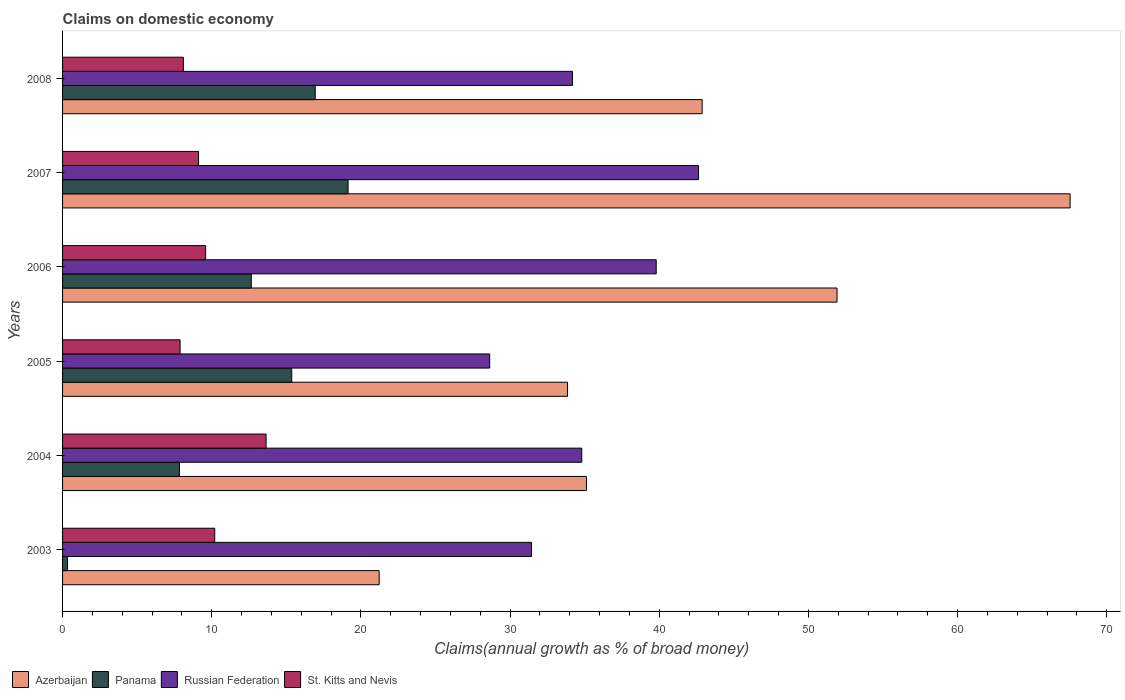How many groups of bars are there?
Your answer should be very brief. 6. Are the number of bars per tick equal to the number of legend labels?
Provide a succinct answer. Yes. How many bars are there on the 1st tick from the top?
Your answer should be compact. 4. How many bars are there on the 3rd tick from the bottom?
Provide a short and direct response. 4. In how many cases, is the number of bars for a given year not equal to the number of legend labels?
Your response must be concise. 0. What is the percentage of broad money claimed on domestic economy in Russian Federation in 2006?
Provide a succinct answer. 39.8. Across all years, what is the maximum percentage of broad money claimed on domestic economy in Azerbaijan?
Ensure brevity in your answer.  67.55. Across all years, what is the minimum percentage of broad money claimed on domestic economy in Azerbaijan?
Give a very brief answer. 21.23. In which year was the percentage of broad money claimed on domestic economy in Azerbaijan maximum?
Offer a very short reply. 2007. What is the total percentage of broad money claimed on domestic economy in Russian Federation in the graph?
Your response must be concise. 211.51. What is the difference between the percentage of broad money claimed on domestic economy in Russian Federation in 2005 and that in 2007?
Offer a terse response. -14. What is the difference between the percentage of broad money claimed on domestic economy in Panama in 2004 and the percentage of broad money claimed on domestic economy in Azerbaijan in 2007?
Provide a succinct answer. -59.71. What is the average percentage of broad money claimed on domestic economy in Azerbaijan per year?
Keep it short and to the point. 42.09. In the year 2004, what is the difference between the percentage of broad money claimed on domestic economy in Panama and percentage of broad money claimed on domestic economy in Azerbaijan?
Your response must be concise. -27.29. In how many years, is the percentage of broad money claimed on domestic economy in Panama greater than 58 %?
Offer a terse response. 0. What is the ratio of the percentage of broad money claimed on domestic economy in Russian Federation in 2003 to that in 2004?
Provide a short and direct response. 0.9. Is the percentage of broad money claimed on domestic economy in Russian Federation in 2006 less than that in 2008?
Provide a short and direct response. No. What is the difference between the highest and the second highest percentage of broad money claimed on domestic economy in Panama?
Keep it short and to the point. 2.2. What is the difference between the highest and the lowest percentage of broad money claimed on domestic economy in Panama?
Give a very brief answer. 18.81. Is the sum of the percentage of broad money claimed on domestic economy in Azerbaijan in 2004 and 2006 greater than the maximum percentage of broad money claimed on domestic economy in St. Kitts and Nevis across all years?
Offer a terse response. Yes. Is it the case that in every year, the sum of the percentage of broad money claimed on domestic economy in Russian Federation and percentage of broad money claimed on domestic economy in Panama is greater than the sum of percentage of broad money claimed on domestic economy in St. Kitts and Nevis and percentage of broad money claimed on domestic economy in Azerbaijan?
Ensure brevity in your answer.  No. What does the 4th bar from the top in 2008 represents?
Your answer should be very brief. Azerbaijan. What does the 2nd bar from the bottom in 2004 represents?
Provide a short and direct response. Panama. How many bars are there?
Provide a succinct answer. 24. Are all the bars in the graph horizontal?
Your answer should be compact. Yes. How many years are there in the graph?
Ensure brevity in your answer.  6. Does the graph contain any zero values?
Offer a very short reply. No. What is the title of the graph?
Your answer should be compact. Claims on domestic economy. What is the label or title of the X-axis?
Offer a terse response. Claims(annual growth as % of broad money). What is the label or title of the Y-axis?
Make the answer very short. Years. What is the Claims(annual growth as % of broad money) of Azerbaijan in 2003?
Make the answer very short. 21.23. What is the Claims(annual growth as % of broad money) of Panama in 2003?
Your response must be concise. 0.33. What is the Claims(annual growth as % of broad money) of Russian Federation in 2003?
Offer a very short reply. 31.44. What is the Claims(annual growth as % of broad money) of St. Kitts and Nevis in 2003?
Your answer should be compact. 10.2. What is the Claims(annual growth as % of broad money) of Azerbaijan in 2004?
Ensure brevity in your answer.  35.12. What is the Claims(annual growth as % of broad money) of Panama in 2004?
Ensure brevity in your answer.  7.83. What is the Claims(annual growth as % of broad money) of Russian Federation in 2004?
Keep it short and to the point. 34.81. What is the Claims(annual growth as % of broad money) of St. Kitts and Nevis in 2004?
Make the answer very short. 13.65. What is the Claims(annual growth as % of broad money) of Azerbaijan in 2005?
Offer a very short reply. 33.85. What is the Claims(annual growth as % of broad money) in Panama in 2005?
Make the answer very short. 15.36. What is the Claims(annual growth as % of broad money) of Russian Federation in 2005?
Your response must be concise. 28.63. What is the Claims(annual growth as % of broad money) in St. Kitts and Nevis in 2005?
Provide a short and direct response. 7.88. What is the Claims(annual growth as % of broad money) in Azerbaijan in 2006?
Your answer should be compact. 51.92. What is the Claims(annual growth as % of broad money) of Panama in 2006?
Your response must be concise. 12.65. What is the Claims(annual growth as % of broad money) in Russian Federation in 2006?
Give a very brief answer. 39.8. What is the Claims(annual growth as % of broad money) of St. Kitts and Nevis in 2006?
Give a very brief answer. 9.59. What is the Claims(annual growth as % of broad money) of Azerbaijan in 2007?
Offer a very short reply. 67.55. What is the Claims(annual growth as % of broad money) in Panama in 2007?
Give a very brief answer. 19.14. What is the Claims(annual growth as % of broad money) in Russian Federation in 2007?
Your answer should be very brief. 42.64. What is the Claims(annual growth as % of broad money) of St. Kitts and Nevis in 2007?
Offer a very short reply. 9.12. What is the Claims(annual growth as % of broad money) in Azerbaijan in 2008?
Make the answer very short. 42.88. What is the Claims(annual growth as % of broad money) in Panama in 2008?
Your answer should be compact. 16.94. What is the Claims(annual growth as % of broad money) of Russian Federation in 2008?
Your response must be concise. 34.19. What is the Claims(annual growth as % of broad money) in St. Kitts and Nevis in 2008?
Your answer should be compact. 8.1. Across all years, what is the maximum Claims(annual growth as % of broad money) of Azerbaijan?
Provide a succinct answer. 67.55. Across all years, what is the maximum Claims(annual growth as % of broad money) in Panama?
Your answer should be very brief. 19.14. Across all years, what is the maximum Claims(annual growth as % of broad money) in Russian Federation?
Provide a succinct answer. 42.64. Across all years, what is the maximum Claims(annual growth as % of broad money) in St. Kitts and Nevis?
Give a very brief answer. 13.65. Across all years, what is the minimum Claims(annual growth as % of broad money) of Azerbaijan?
Offer a terse response. 21.23. Across all years, what is the minimum Claims(annual growth as % of broad money) in Panama?
Your answer should be compact. 0.33. Across all years, what is the minimum Claims(annual growth as % of broad money) of Russian Federation?
Ensure brevity in your answer.  28.63. Across all years, what is the minimum Claims(annual growth as % of broad money) of St. Kitts and Nevis?
Your answer should be very brief. 7.88. What is the total Claims(annual growth as % of broad money) in Azerbaijan in the graph?
Offer a very short reply. 252.56. What is the total Claims(annual growth as % of broad money) of Panama in the graph?
Provide a short and direct response. 72.26. What is the total Claims(annual growth as % of broad money) in Russian Federation in the graph?
Your answer should be compact. 211.51. What is the total Claims(annual growth as % of broad money) of St. Kitts and Nevis in the graph?
Ensure brevity in your answer.  58.53. What is the difference between the Claims(annual growth as % of broad money) of Azerbaijan in 2003 and that in 2004?
Give a very brief answer. -13.9. What is the difference between the Claims(annual growth as % of broad money) of Panama in 2003 and that in 2004?
Provide a short and direct response. -7.5. What is the difference between the Claims(annual growth as % of broad money) of Russian Federation in 2003 and that in 2004?
Your answer should be very brief. -3.37. What is the difference between the Claims(annual growth as % of broad money) of St. Kitts and Nevis in 2003 and that in 2004?
Your response must be concise. -3.44. What is the difference between the Claims(annual growth as % of broad money) of Azerbaijan in 2003 and that in 2005?
Ensure brevity in your answer.  -12.63. What is the difference between the Claims(annual growth as % of broad money) of Panama in 2003 and that in 2005?
Provide a short and direct response. -15.03. What is the difference between the Claims(annual growth as % of broad money) of Russian Federation in 2003 and that in 2005?
Give a very brief answer. 2.81. What is the difference between the Claims(annual growth as % of broad money) in St. Kitts and Nevis in 2003 and that in 2005?
Offer a very short reply. 2.32. What is the difference between the Claims(annual growth as % of broad money) in Azerbaijan in 2003 and that in 2006?
Keep it short and to the point. -30.7. What is the difference between the Claims(annual growth as % of broad money) of Panama in 2003 and that in 2006?
Your answer should be very brief. -12.32. What is the difference between the Claims(annual growth as % of broad money) of Russian Federation in 2003 and that in 2006?
Provide a succinct answer. -8.36. What is the difference between the Claims(annual growth as % of broad money) of St. Kitts and Nevis in 2003 and that in 2006?
Your answer should be compact. 0.61. What is the difference between the Claims(annual growth as % of broad money) of Azerbaijan in 2003 and that in 2007?
Provide a short and direct response. -46.32. What is the difference between the Claims(annual growth as % of broad money) of Panama in 2003 and that in 2007?
Provide a succinct answer. -18.81. What is the difference between the Claims(annual growth as % of broad money) in Russian Federation in 2003 and that in 2007?
Your answer should be very brief. -11.2. What is the difference between the Claims(annual growth as % of broad money) in St. Kitts and Nevis in 2003 and that in 2007?
Keep it short and to the point. 1.09. What is the difference between the Claims(annual growth as % of broad money) in Azerbaijan in 2003 and that in 2008?
Your answer should be very brief. -21.66. What is the difference between the Claims(annual growth as % of broad money) of Panama in 2003 and that in 2008?
Your answer should be very brief. -16.61. What is the difference between the Claims(annual growth as % of broad money) of Russian Federation in 2003 and that in 2008?
Offer a terse response. -2.75. What is the difference between the Claims(annual growth as % of broad money) in St. Kitts and Nevis in 2003 and that in 2008?
Give a very brief answer. 2.1. What is the difference between the Claims(annual growth as % of broad money) in Azerbaijan in 2004 and that in 2005?
Keep it short and to the point. 1.27. What is the difference between the Claims(annual growth as % of broad money) in Panama in 2004 and that in 2005?
Give a very brief answer. -7.53. What is the difference between the Claims(annual growth as % of broad money) in Russian Federation in 2004 and that in 2005?
Offer a terse response. 6.17. What is the difference between the Claims(annual growth as % of broad money) of St. Kitts and Nevis in 2004 and that in 2005?
Your answer should be compact. 5.77. What is the difference between the Claims(annual growth as % of broad money) in Azerbaijan in 2004 and that in 2006?
Give a very brief answer. -16.8. What is the difference between the Claims(annual growth as % of broad money) of Panama in 2004 and that in 2006?
Give a very brief answer. -4.82. What is the difference between the Claims(annual growth as % of broad money) of Russian Federation in 2004 and that in 2006?
Your answer should be compact. -4.99. What is the difference between the Claims(annual growth as % of broad money) of St. Kitts and Nevis in 2004 and that in 2006?
Provide a succinct answer. 4.05. What is the difference between the Claims(annual growth as % of broad money) in Azerbaijan in 2004 and that in 2007?
Ensure brevity in your answer.  -32.43. What is the difference between the Claims(annual growth as % of broad money) in Panama in 2004 and that in 2007?
Keep it short and to the point. -11.31. What is the difference between the Claims(annual growth as % of broad money) in Russian Federation in 2004 and that in 2007?
Provide a succinct answer. -7.83. What is the difference between the Claims(annual growth as % of broad money) in St. Kitts and Nevis in 2004 and that in 2007?
Your answer should be compact. 4.53. What is the difference between the Claims(annual growth as % of broad money) in Azerbaijan in 2004 and that in 2008?
Provide a short and direct response. -7.76. What is the difference between the Claims(annual growth as % of broad money) in Panama in 2004 and that in 2008?
Keep it short and to the point. -9.1. What is the difference between the Claims(annual growth as % of broad money) in Russian Federation in 2004 and that in 2008?
Your answer should be compact. 0.62. What is the difference between the Claims(annual growth as % of broad money) of St. Kitts and Nevis in 2004 and that in 2008?
Offer a very short reply. 5.55. What is the difference between the Claims(annual growth as % of broad money) in Azerbaijan in 2005 and that in 2006?
Provide a short and direct response. -18.07. What is the difference between the Claims(annual growth as % of broad money) of Panama in 2005 and that in 2006?
Your response must be concise. 2.71. What is the difference between the Claims(annual growth as % of broad money) in Russian Federation in 2005 and that in 2006?
Your answer should be compact. -11.17. What is the difference between the Claims(annual growth as % of broad money) in St. Kitts and Nevis in 2005 and that in 2006?
Your answer should be very brief. -1.71. What is the difference between the Claims(annual growth as % of broad money) of Azerbaijan in 2005 and that in 2007?
Provide a succinct answer. -33.7. What is the difference between the Claims(annual growth as % of broad money) of Panama in 2005 and that in 2007?
Your answer should be very brief. -3.78. What is the difference between the Claims(annual growth as % of broad money) in Russian Federation in 2005 and that in 2007?
Your answer should be very brief. -14. What is the difference between the Claims(annual growth as % of broad money) in St. Kitts and Nevis in 2005 and that in 2007?
Offer a terse response. -1.24. What is the difference between the Claims(annual growth as % of broad money) in Azerbaijan in 2005 and that in 2008?
Offer a terse response. -9.03. What is the difference between the Claims(annual growth as % of broad money) in Panama in 2005 and that in 2008?
Offer a terse response. -1.58. What is the difference between the Claims(annual growth as % of broad money) in Russian Federation in 2005 and that in 2008?
Give a very brief answer. -5.55. What is the difference between the Claims(annual growth as % of broad money) of St. Kitts and Nevis in 2005 and that in 2008?
Keep it short and to the point. -0.22. What is the difference between the Claims(annual growth as % of broad money) in Azerbaijan in 2006 and that in 2007?
Provide a short and direct response. -15.63. What is the difference between the Claims(annual growth as % of broad money) in Panama in 2006 and that in 2007?
Provide a short and direct response. -6.49. What is the difference between the Claims(annual growth as % of broad money) in Russian Federation in 2006 and that in 2007?
Offer a very short reply. -2.84. What is the difference between the Claims(annual growth as % of broad money) of St. Kitts and Nevis in 2006 and that in 2007?
Ensure brevity in your answer.  0.47. What is the difference between the Claims(annual growth as % of broad money) in Azerbaijan in 2006 and that in 2008?
Provide a short and direct response. 9.04. What is the difference between the Claims(annual growth as % of broad money) in Panama in 2006 and that in 2008?
Provide a short and direct response. -4.29. What is the difference between the Claims(annual growth as % of broad money) in Russian Federation in 2006 and that in 2008?
Your answer should be very brief. 5.61. What is the difference between the Claims(annual growth as % of broad money) in St. Kitts and Nevis in 2006 and that in 2008?
Provide a short and direct response. 1.49. What is the difference between the Claims(annual growth as % of broad money) of Azerbaijan in 2007 and that in 2008?
Offer a very short reply. 24.67. What is the difference between the Claims(annual growth as % of broad money) of Panama in 2007 and that in 2008?
Make the answer very short. 2.2. What is the difference between the Claims(annual growth as % of broad money) of Russian Federation in 2007 and that in 2008?
Provide a short and direct response. 8.45. What is the difference between the Claims(annual growth as % of broad money) in St. Kitts and Nevis in 2007 and that in 2008?
Your response must be concise. 1.02. What is the difference between the Claims(annual growth as % of broad money) in Azerbaijan in 2003 and the Claims(annual growth as % of broad money) in Panama in 2004?
Your answer should be compact. 13.39. What is the difference between the Claims(annual growth as % of broad money) in Azerbaijan in 2003 and the Claims(annual growth as % of broad money) in Russian Federation in 2004?
Keep it short and to the point. -13.58. What is the difference between the Claims(annual growth as % of broad money) of Azerbaijan in 2003 and the Claims(annual growth as % of broad money) of St. Kitts and Nevis in 2004?
Keep it short and to the point. 7.58. What is the difference between the Claims(annual growth as % of broad money) of Panama in 2003 and the Claims(annual growth as % of broad money) of Russian Federation in 2004?
Offer a very short reply. -34.47. What is the difference between the Claims(annual growth as % of broad money) in Panama in 2003 and the Claims(annual growth as % of broad money) in St. Kitts and Nevis in 2004?
Make the answer very short. -13.31. What is the difference between the Claims(annual growth as % of broad money) in Russian Federation in 2003 and the Claims(annual growth as % of broad money) in St. Kitts and Nevis in 2004?
Your response must be concise. 17.8. What is the difference between the Claims(annual growth as % of broad money) in Azerbaijan in 2003 and the Claims(annual growth as % of broad money) in Panama in 2005?
Offer a terse response. 5.86. What is the difference between the Claims(annual growth as % of broad money) of Azerbaijan in 2003 and the Claims(annual growth as % of broad money) of Russian Federation in 2005?
Keep it short and to the point. -7.41. What is the difference between the Claims(annual growth as % of broad money) in Azerbaijan in 2003 and the Claims(annual growth as % of broad money) in St. Kitts and Nevis in 2005?
Keep it short and to the point. 13.35. What is the difference between the Claims(annual growth as % of broad money) in Panama in 2003 and the Claims(annual growth as % of broad money) in Russian Federation in 2005?
Provide a succinct answer. -28.3. What is the difference between the Claims(annual growth as % of broad money) of Panama in 2003 and the Claims(annual growth as % of broad money) of St. Kitts and Nevis in 2005?
Your answer should be very brief. -7.54. What is the difference between the Claims(annual growth as % of broad money) in Russian Federation in 2003 and the Claims(annual growth as % of broad money) in St. Kitts and Nevis in 2005?
Provide a succinct answer. 23.56. What is the difference between the Claims(annual growth as % of broad money) in Azerbaijan in 2003 and the Claims(annual growth as % of broad money) in Panama in 2006?
Provide a succinct answer. 8.57. What is the difference between the Claims(annual growth as % of broad money) in Azerbaijan in 2003 and the Claims(annual growth as % of broad money) in Russian Federation in 2006?
Your response must be concise. -18.57. What is the difference between the Claims(annual growth as % of broad money) of Azerbaijan in 2003 and the Claims(annual growth as % of broad money) of St. Kitts and Nevis in 2006?
Ensure brevity in your answer.  11.63. What is the difference between the Claims(annual growth as % of broad money) of Panama in 2003 and the Claims(annual growth as % of broad money) of Russian Federation in 2006?
Offer a very short reply. -39.47. What is the difference between the Claims(annual growth as % of broad money) in Panama in 2003 and the Claims(annual growth as % of broad money) in St. Kitts and Nevis in 2006?
Offer a very short reply. -9.26. What is the difference between the Claims(annual growth as % of broad money) of Russian Federation in 2003 and the Claims(annual growth as % of broad money) of St. Kitts and Nevis in 2006?
Offer a very short reply. 21.85. What is the difference between the Claims(annual growth as % of broad money) of Azerbaijan in 2003 and the Claims(annual growth as % of broad money) of Panama in 2007?
Your answer should be very brief. 2.08. What is the difference between the Claims(annual growth as % of broad money) in Azerbaijan in 2003 and the Claims(annual growth as % of broad money) in Russian Federation in 2007?
Give a very brief answer. -21.41. What is the difference between the Claims(annual growth as % of broad money) of Azerbaijan in 2003 and the Claims(annual growth as % of broad money) of St. Kitts and Nevis in 2007?
Make the answer very short. 12.11. What is the difference between the Claims(annual growth as % of broad money) of Panama in 2003 and the Claims(annual growth as % of broad money) of Russian Federation in 2007?
Your response must be concise. -42.31. What is the difference between the Claims(annual growth as % of broad money) in Panama in 2003 and the Claims(annual growth as % of broad money) in St. Kitts and Nevis in 2007?
Make the answer very short. -8.78. What is the difference between the Claims(annual growth as % of broad money) in Russian Federation in 2003 and the Claims(annual growth as % of broad money) in St. Kitts and Nevis in 2007?
Make the answer very short. 22.32. What is the difference between the Claims(annual growth as % of broad money) in Azerbaijan in 2003 and the Claims(annual growth as % of broad money) in Panama in 2008?
Offer a terse response. 4.29. What is the difference between the Claims(annual growth as % of broad money) in Azerbaijan in 2003 and the Claims(annual growth as % of broad money) in Russian Federation in 2008?
Your answer should be compact. -12.96. What is the difference between the Claims(annual growth as % of broad money) in Azerbaijan in 2003 and the Claims(annual growth as % of broad money) in St. Kitts and Nevis in 2008?
Offer a terse response. 13.13. What is the difference between the Claims(annual growth as % of broad money) of Panama in 2003 and the Claims(annual growth as % of broad money) of Russian Federation in 2008?
Provide a short and direct response. -33.85. What is the difference between the Claims(annual growth as % of broad money) of Panama in 2003 and the Claims(annual growth as % of broad money) of St. Kitts and Nevis in 2008?
Provide a succinct answer. -7.76. What is the difference between the Claims(annual growth as % of broad money) in Russian Federation in 2003 and the Claims(annual growth as % of broad money) in St. Kitts and Nevis in 2008?
Provide a short and direct response. 23.34. What is the difference between the Claims(annual growth as % of broad money) in Azerbaijan in 2004 and the Claims(annual growth as % of broad money) in Panama in 2005?
Provide a short and direct response. 19.76. What is the difference between the Claims(annual growth as % of broad money) of Azerbaijan in 2004 and the Claims(annual growth as % of broad money) of Russian Federation in 2005?
Keep it short and to the point. 6.49. What is the difference between the Claims(annual growth as % of broad money) in Azerbaijan in 2004 and the Claims(annual growth as % of broad money) in St. Kitts and Nevis in 2005?
Provide a succinct answer. 27.25. What is the difference between the Claims(annual growth as % of broad money) in Panama in 2004 and the Claims(annual growth as % of broad money) in Russian Federation in 2005?
Provide a succinct answer. -20.8. What is the difference between the Claims(annual growth as % of broad money) of Panama in 2004 and the Claims(annual growth as % of broad money) of St. Kitts and Nevis in 2005?
Give a very brief answer. -0.04. What is the difference between the Claims(annual growth as % of broad money) in Russian Federation in 2004 and the Claims(annual growth as % of broad money) in St. Kitts and Nevis in 2005?
Make the answer very short. 26.93. What is the difference between the Claims(annual growth as % of broad money) of Azerbaijan in 2004 and the Claims(annual growth as % of broad money) of Panama in 2006?
Provide a succinct answer. 22.47. What is the difference between the Claims(annual growth as % of broad money) of Azerbaijan in 2004 and the Claims(annual growth as % of broad money) of Russian Federation in 2006?
Provide a short and direct response. -4.68. What is the difference between the Claims(annual growth as % of broad money) of Azerbaijan in 2004 and the Claims(annual growth as % of broad money) of St. Kitts and Nevis in 2006?
Make the answer very short. 25.53. What is the difference between the Claims(annual growth as % of broad money) in Panama in 2004 and the Claims(annual growth as % of broad money) in Russian Federation in 2006?
Give a very brief answer. -31.97. What is the difference between the Claims(annual growth as % of broad money) of Panama in 2004 and the Claims(annual growth as % of broad money) of St. Kitts and Nevis in 2006?
Offer a terse response. -1.76. What is the difference between the Claims(annual growth as % of broad money) in Russian Federation in 2004 and the Claims(annual growth as % of broad money) in St. Kitts and Nevis in 2006?
Ensure brevity in your answer.  25.22. What is the difference between the Claims(annual growth as % of broad money) of Azerbaijan in 2004 and the Claims(annual growth as % of broad money) of Panama in 2007?
Your answer should be compact. 15.98. What is the difference between the Claims(annual growth as % of broad money) of Azerbaijan in 2004 and the Claims(annual growth as % of broad money) of Russian Federation in 2007?
Make the answer very short. -7.52. What is the difference between the Claims(annual growth as % of broad money) in Azerbaijan in 2004 and the Claims(annual growth as % of broad money) in St. Kitts and Nevis in 2007?
Your response must be concise. 26.01. What is the difference between the Claims(annual growth as % of broad money) in Panama in 2004 and the Claims(annual growth as % of broad money) in Russian Federation in 2007?
Offer a very short reply. -34.8. What is the difference between the Claims(annual growth as % of broad money) of Panama in 2004 and the Claims(annual growth as % of broad money) of St. Kitts and Nevis in 2007?
Provide a short and direct response. -1.28. What is the difference between the Claims(annual growth as % of broad money) in Russian Federation in 2004 and the Claims(annual growth as % of broad money) in St. Kitts and Nevis in 2007?
Your response must be concise. 25.69. What is the difference between the Claims(annual growth as % of broad money) in Azerbaijan in 2004 and the Claims(annual growth as % of broad money) in Panama in 2008?
Offer a very short reply. 18.18. What is the difference between the Claims(annual growth as % of broad money) of Azerbaijan in 2004 and the Claims(annual growth as % of broad money) of Russian Federation in 2008?
Provide a short and direct response. 0.94. What is the difference between the Claims(annual growth as % of broad money) of Azerbaijan in 2004 and the Claims(annual growth as % of broad money) of St. Kitts and Nevis in 2008?
Your answer should be very brief. 27.03. What is the difference between the Claims(annual growth as % of broad money) in Panama in 2004 and the Claims(annual growth as % of broad money) in Russian Federation in 2008?
Offer a terse response. -26.35. What is the difference between the Claims(annual growth as % of broad money) in Panama in 2004 and the Claims(annual growth as % of broad money) in St. Kitts and Nevis in 2008?
Make the answer very short. -0.26. What is the difference between the Claims(annual growth as % of broad money) in Russian Federation in 2004 and the Claims(annual growth as % of broad money) in St. Kitts and Nevis in 2008?
Provide a short and direct response. 26.71. What is the difference between the Claims(annual growth as % of broad money) of Azerbaijan in 2005 and the Claims(annual growth as % of broad money) of Panama in 2006?
Offer a very short reply. 21.2. What is the difference between the Claims(annual growth as % of broad money) of Azerbaijan in 2005 and the Claims(annual growth as % of broad money) of Russian Federation in 2006?
Your answer should be compact. -5.95. What is the difference between the Claims(annual growth as % of broad money) of Azerbaijan in 2005 and the Claims(annual growth as % of broad money) of St. Kitts and Nevis in 2006?
Make the answer very short. 24.26. What is the difference between the Claims(annual growth as % of broad money) of Panama in 2005 and the Claims(annual growth as % of broad money) of Russian Federation in 2006?
Your response must be concise. -24.44. What is the difference between the Claims(annual growth as % of broad money) in Panama in 2005 and the Claims(annual growth as % of broad money) in St. Kitts and Nevis in 2006?
Your response must be concise. 5.77. What is the difference between the Claims(annual growth as % of broad money) of Russian Federation in 2005 and the Claims(annual growth as % of broad money) of St. Kitts and Nevis in 2006?
Give a very brief answer. 19.04. What is the difference between the Claims(annual growth as % of broad money) in Azerbaijan in 2005 and the Claims(annual growth as % of broad money) in Panama in 2007?
Give a very brief answer. 14.71. What is the difference between the Claims(annual growth as % of broad money) in Azerbaijan in 2005 and the Claims(annual growth as % of broad money) in Russian Federation in 2007?
Ensure brevity in your answer.  -8.78. What is the difference between the Claims(annual growth as % of broad money) in Azerbaijan in 2005 and the Claims(annual growth as % of broad money) in St. Kitts and Nevis in 2007?
Provide a short and direct response. 24.74. What is the difference between the Claims(annual growth as % of broad money) of Panama in 2005 and the Claims(annual growth as % of broad money) of Russian Federation in 2007?
Your response must be concise. -27.28. What is the difference between the Claims(annual growth as % of broad money) of Panama in 2005 and the Claims(annual growth as % of broad money) of St. Kitts and Nevis in 2007?
Make the answer very short. 6.25. What is the difference between the Claims(annual growth as % of broad money) of Russian Federation in 2005 and the Claims(annual growth as % of broad money) of St. Kitts and Nevis in 2007?
Your response must be concise. 19.52. What is the difference between the Claims(annual growth as % of broad money) of Azerbaijan in 2005 and the Claims(annual growth as % of broad money) of Panama in 2008?
Give a very brief answer. 16.92. What is the difference between the Claims(annual growth as % of broad money) of Azerbaijan in 2005 and the Claims(annual growth as % of broad money) of Russian Federation in 2008?
Offer a very short reply. -0.33. What is the difference between the Claims(annual growth as % of broad money) of Azerbaijan in 2005 and the Claims(annual growth as % of broad money) of St. Kitts and Nevis in 2008?
Make the answer very short. 25.76. What is the difference between the Claims(annual growth as % of broad money) in Panama in 2005 and the Claims(annual growth as % of broad money) in Russian Federation in 2008?
Give a very brief answer. -18.82. What is the difference between the Claims(annual growth as % of broad money) of Panama in 2005 and the Claims(annual growth as % of broad money) of St. Kitts and Nevis in 2008?
Keep it short and to the point. 7.26. What is the difference between the Claims(annual growth as % of broad money) of Russian Federation in 2005 and the Claims(annual growth as % of broad money) of St. Kitts and Nevis in 2008?
Ensure brevity in your answer.  20.54. What is the difference between the Claims(annual growth as % of broad money) of Azerbaijan in 2006 and the Claims(annual growth as % of broad money) of Panama in 2007?
Make the answer very short. 32.78. What is the difference between the Claims(annual growth as % of broad money) in Azerbaijan in 2006 and the Claims(annual growth as % of broad money) in Russian Federation in 2007?
Give a very brief answer. 9.28. What is the difference between the Claims(annual growth as % of broad money) in Azerbaijan in 2006 and the Claims(annual growth as % of broad money) in St. Kitts and Nevis in 2007?
Give a very brief answer. 42.8. What is the difference between the Claims(annual growth as % of broad money) of Panama in 2006 and the Claims(annual growth as % of broad money) of Russian Federation in 2007?
Keep it short and to the point. -29.99. What is the difference between the Claims(annual growth as % of broad money) of Panama in 2006 and the Claims(annual growth as % of broad money) of St. Kitts and Nevis in 2007?
Your response must be concise. 3.54. What is the difference between the Claims(annual growth as % of broad money) in Russian Federation in 2006 and the Claims(annual growth as % of broad money) in St. Kitts and Nevis in 2007?
Give a very brief answer. 30.68. What is the difference between the Claims(annual growth as % of broad money) of Azerbaijan in 2006 and the Claims(annual growth as % of broad money) of Panama in 2008?
Give a very brief answer. 34.98. What is the difference between the Claims(annual growth as % of broad money) in Azerbaijan in 2006 and the Claims(annual growth as % of broad money) in Russian Federation in 2008?
Give a very brief answer. 17.73. What is the difference between the Claims(annual growth as % of broad money) of Azerbaijan in 2006 and the Claims(annual growth as % of broad money) of St. Kitts and Nevis in 2008?
Keep it short and to the point. 43.82. What is the difference between the Claims(annual growth as % of broad money) in Panama in 2006 and the Claims(annual growth as % of broad money) in Russian Federation in 2008?
Offer a very short reply. -21.54. What is the difference between the Claims(annual growth as % of broad money) of Panama in 2006 and the Claims(annual growth as % of broad money) of St. Kitts and Nevis in 2008?
Make the answer very short. 4.55. What is the difference between the Claims(annual growth as % of broad money) in Russian Federation in 2006 and the Claims(annual growth as % of broad money) in St. Kitts and Nevis in 2008?
Offer a very short reply. 31.7. What is the difference between the Claims(annual growth as % of broad money) in Azerbaijan in 2007 and the Claims(annual growth as % of broad money) in Panama in 2008?
Provide a succinct answer. 50.61. What is the difference between the Claims(annual growth as % of broad money) in Azerbaijan in 2007 and the Claims(annual growth as % of broad money) in Russian Federation in 2008?
Offer a very short reply. 33.36. What is the difference between the Claims(annual growth as % of broad money) of Azerbaijan in 2007 and the Claims(annual growth as % of broad money) of St. Kitts and Nevis in 2008?
Give a very brief answer. 59.45. What is the difference between the Claims(annual growth as % of broad money) of Panama in 2007 and the Claims(annual growth as % of broad money) of Russian Federation in 2008?
Offer a very short reply. -15.05. What is the difference between the Claims(annual growth as % of broad money) of Panama in 2007 and the Claims(annual growth as % of broad money) of St. Kitts and Nevis in 2008?
Your answer should be compact. 11.04. What is the difference between the Claims(annual growth as % of broad money) of Russian Federation in 2007 and the Claims(annual growth as % of broad money) of St. Kitts and Nevis in 2008?
Provide a short and direct response. 34.54. What is the average Claims(annual growth as % of broad money) in Azerbaijan per year?
Your answer should be very brief. 42.09. What is the average Claims(annual growth as % of broad money) of Panama per year?
Make the answer very short. 12.04. What is the average Claims(annual growth as % of broad money) of Russian Federation per year?
Provide a succinct answer. 35.25. What is the average Claims(annual growth as % of broad money) in St. Kitts and Nevis per year?
Make the answer very short. 9.76. In the year 2003, what is the difference between the Claims(annual growth as % of broad money) of Azerbaijan and Claims(annual growth as % of broad money) of Panama?
Offer a very short reply. 20.89. In the year 2003, what is the difference between the Claims(annual growth as % of broad money) in Azerbaijan and Claims(annual growth as % of broad money) in Russian Federation?
Offer a very short reply. -10.21. In the year 2003, what is the difference between the Claims(annual growth as % of broad money) of Azerbaijan and Claims(annual growth as % of broad money) of St. Kitts and Nevis?
Provide a short and direct response. 11.02. In the year 2003, what is the difference between the Claims(annual growth as % of broad money) in Panama and Claims(annual growth as % of broad money) in Russian Federation?
Offer a very short reply. -31.11. In the year 2003, what is the difference between the Claims(annual growth as % of broad money) of Panama and Claims(annual growth as % of broad money) of St. Kitts and Nevis?
Your answer should be very brief. -9.87. In the year 2003, what is the difference between the Claims(annual growth as % of broad money) of Russian Federation and Claims(annual growth as % of broad money) of St. Kitts and Nevis?
Keep it short and to the point. 21.24. In the year 2004, what is the difference between the Claims(annual growth as % of broad money) of Azerbaijan and Claims(annual growth as % of broad money) of Panama?
Provide a succinct answer. 27.29. In the year 2004, what is the difference between the Claims(annual growth as % of broad money) of Azerbaijan and Claims(annual growth as % of broad money) of Russian Federation?
Offer a very short reply. 0.32. In the year 2004, what is the difference between the Claims(annual growth as % of broad money) in Azerbaijan and Claims(annual growth as % of broad money) in St. Kitts and Nevis?
Your answer should be compact. 21.48. In the year 2004, what is the difference between the Claims(annual growth as % of broad money) in Panama and Claims(annual growth as % of broad money) in Russian Federation?
Your answer should be very brief. -26.97. In the year 2004, what is the difference between the Claims(annual growth as % of broad money) in Panama and Claims(annual growth as % of broad money) in St. Kitts and Nevis?
Make the answer very short. -5.81. In the year 2004, what is the difference between the Claims(annual growth as % of broad money) of Russian Federation and Claims(annual growth as % of broad money) of St. Kitts and Nevis?
Offer a terse response. 21.16. In the year 2005, what is the difference between the Claims(annual growth as % of broad money) in Azerbaijan and Claims(annual growth as % of broad money) in Panama?
Your response must be concise. 18.49. In the year 2005, what is the difference between the Claims(annual growth as % of broad money) in Azerbaijan and Claims(annual growth as % of broad money) in Russian Federation?
Provide a succinct answer. 5.22. In the year 2005, what is the difference between the Claims(annual growth as % of broad money) of Azerbaijan and Claims(annual growth as % of broad money) of St. Kitts and Nevis?
Your answer should be compact. 25.98. In the year 2005, what is the difference between the Claims(annual growth as % of broad money) of Panama and Claims(annual growth as % of broad money) of Russian Federation?
Keep it short and to the point. -13.27. In the year 2005, what is the difference between the Claims(annual growth as % of broad money) in Panama and Claims(annual growth as % of broad money) in St. Kitts and Nevis?
Your response must be concise. 7.48. In the year 2005, what is the difference between the Claims(annual growth as % of broad money) in Russian Federation and Claims(annual growth as % of broad money) in St. Kitts and Nevis?
Provide a succinct answer. 20.76. In the year 2006, what is the difference between the Claims(annual growth as % of broad money) in Azerbaijan and Claims(annual growth as % of broad money) in Panama?
Give a very brief answer. 39.27. In the year 2006, what is the difference between the Claims(annual growth as % of broad money) in Azerbaijan and Claims(annual growth as % of broad money) in Russian Federation?
Your answer should be compact. 12.12. In the year 2006, what is the difference between the Claims(annual growth as % of broad money) in Azerbaijan and Claims(annual growth as % of broad money) in St. Kitts and Nevis?
Your answer should be compact. 42.33. In the year 2006, what is the difference between the Claims(annual growth as % of broad money) of Panama and Claims(annual growth as % of broad money) of Russian Federation?
Your answer should be compact. -27.15. In the year 2006, what is the difference between the Claims(annual growth as % of broad money) in Panama and Claims(annual growth as % of broad money) in St. Kitts and Nevis?
Give a very brief answer. 3.06. In the year 2006, what is the difference between the Claims(annual growth as % of broad money) in Russian Federation and Claims(annual growth as % of broad money) in St. Kitts and Nevis?
Keep it short and to the point. 30.21. In the year 2007, what is the difference between the Claims(annual growth as % of broad money) of Azerbaijan and Claims(annual growth as % of broad money) of Panama?
Your answer should be compact. 48.41. In the year 2007, what is the difference between the Claims(annual growth as % of broad money) of Azerbaijan and Claims(annual growth as % of broad money) of Russian Federation?
Your answer should be very brief. 24.91. In the year 2007, what is the difference between the Claims(annual growth as % of broad money) in Azerbaijan and Claims(annual growth as % of broad money) in St. Kitts and Nevis?
Your answer should be compact. 58.43. In the year 2007, what is the difference between the Claims(annual growth as % of broad money) in Panama and Claims(annual growth as % of broad money) in Russian Federation?
Offer a very short reply. -23.5. In the year 2007, what is the difference between the Claims(annual growth as % of broad money) of Panama and Claims(annual growth as % of broad money) of St. Kitts and Nevis?
Offer a terse response. 10.02. In the year 2007, what is the difference between the Claims(annual growth as % of broad money) in Russian Federation and Claims(annual growth as % of broad money) in St. Kitts and Nevis?
Your response must be concise. 33.52. In the year 2008, what is the difference between the Claims(annual growth as % of broad money) in Azerbaijan and Claims(annual growth as % of broad money) in Panama?
Ensure brevity in your answer.  25.94. In the year 2008, what is the difference between the Claims(annual growth as % of broad money) in Azerbaijan and Claims(annual growth as % of broad money) in Russian Federation?
Offer a very short reply. 8.69. In the year 2008, what is the difference between the Claims(annual growth as % of broad money) in Azerbaijan and Claims(annual growth as % of broad money) in St. Kitts and Nevis?
Provide a succinct answer. 34.78. In the year 2008, what is the difference between the Claims(annual growth as % of broad money) in Panama and Claims(annual growth as % of broad money) in Russian Federation?
Give a very brief answer. -17.25. In the year 2008, what is the difference between the Claims(annual growth as % of broad money) of Panama and Claims(annual growth as % of broad money) of St. Kitts and Nevis?
Keep it short and to the point. 8.84. In the year 2008, what is the difference between the Claims(annual growth as % of broad money) of Russian Federation and Claims(annual growth as % of broad money) of St. Kitts and Nevis?
Your answer should be compact. 26.09. What is the ratio of the Claims(annual growth as % of broad money) in Azerbaijan in 2003 to that in 2004?
Give a very brief answer. 0.6. What is the ratio of the Claims(annual growth as % of broad money) in Panama in 2003 to that in 2004?
Your answer should be very brief. 0.04. What is the ratio of the Claims(annual growth as % of broad money) of Russian Federation in 2003 to that in 2004?
Make the answer very short. 0.9. What is the ratio of the Claims(annual growth as % of broad money) of St. Kitts and Nevis in 2003 to that in 2004?
Keep it short and to the point. 0.75. What is the ratio of the Claims(annual growth as % of broad money) in Azerbaijan in 2003 to that in 2005?
Your response must be concise. 0.63. What is the ratio of the Claims(annual growth as % of broad money) in Panama in 2003 to that in 2005?
Your response must be concise. 0.02. What is the ratio of the Claims(annual growth as % of broad money) of Russian Federation in 2003 to that in 2005?
Your response must be concise. 1.1. What is the ratio of the Claims(annual growth as % of broad money) of St. Kitts and Nevis in 2003 to that in 2005?
Provide a succinct answer. 1.29. What is the ratio of the Claims(annual growth as % of broad money) of Azerbaijan in 2003 to that in 2006?
Offer a very short reply. 0.41. What is the ratio of the Claims(annual growth as % of broad money) in Panama in 2003 to that in 2006?
Offer a very short reply. 0.03. What is the ratio of the Claims(annual growth as % of broad money) in Russian Federation in 2003 to that in 2006?
Keep it short and to the point. 0.79. What is the ratio of the Claims(annual growth as % of broad money) in St. Kitts and Nevis in 2003 to that in 2006?
Ensure brevity in your answer.  1.06. What is the ratio of the Claims(annual growth as % of broad money) of Azerbaijan in 2003 to that in 2007?
Provide a short and direct response. 0.31. What is the ratio of the Claims(annual growth as % of broad money) of Panama in 2003 to that in 2007?
Your answer should be very brief. 0.02. What is the ratio of the Claims(annual growth as % of broad money) in Russian Federation in 2003 to that in 2007?
Your answer should be very brief. 0.74. What is the ratio of the Claims(annual growth as % of broad money) in St. Kitts and Nevis in 2003 to that in 2007?
Provide a short and direct response. 1.12. What is the ratio of the Claims(annual growth as % of broad money) in Azerbaijan in 2003 to that in 2008?
Keep it short and to the point. 0.49. What is the ratio of the Claims(annual growth as % of broad money) in Panama in 2003 to that in 2008?
Offer a terse response. 0.02. What is the ratio of the Claims(annual growth as % of broad money) of Russian Federation in 2003 to that in 2008?
Your answer should be compact. 0.92. What is the ratio of the Claims(annual growth as % of broad money) in St. Kitts and Nevis in 2003 to that in 2008?
Your answer should be compact. 1.26. What is the ratio of the Claims(annual growth as % of broad money) of Azerbaijan in 2004 to that in 2005?
Offer a terse response. 1.04. What is the ratio of the Claims(annual growth as % of broad money) of Panama in 2004 to that in 2005?
Your answer should be very brief. 0.51. What is the ratio of the Claims(annual growth as % of broad money) in Russian Federation in 2004 to that in 2005?
Ensure brevity in your answer.  1.22. What is the ratio of the Claims(annual growth as % of broad money) of St. Kitts and Nevis in 2004 to that in 2005?
Your response must be concise. 1.73. What is the ratio of the Claims(annual growth as % of broad money) in Azerbaijan in 2004 to that in 2006?
Your response must be concise. 0.68. What is the ratio of the Claims(annual growth as % of broad money) in Panama in 2004 to that in 2006?
Your answer should be very brief. 0.62. What is the ratio of the Claims(annual growth as % of broad money) of Russian Federation in 2004 to that in 2006?
Provide a succinct answer. 0.87. What is the ratio of the Claims(annual growth as % of broad money) of St. Kitts and Nevis in 2004 to that in 2006?
Your answer should be compact. 1.42. What is the ratio of the Claims(annual growth as % of broad money) in Azerbaijan in 2004 to that in 2007?
Your response must be concise. 0.52. What is the ratio of the Claims(annual growth as % of broad money) of Panama in 2004 to that in 2007?
Your response must be concise. 0.41. What is the ratio of the Claims(annual growth as % of broad money) in Russian Federation in 2004 to that in 2007?
Offer a very short reply. 0.82. What is the ratio of the Claims(annual growth as % of broad money) of St. Kitts and Nevis in 2004 to that in 2007?
Your answer should be compact. 1.5. What is the ratio of the Claims(annual growth as % of broad money) in Azerbaijan in 2004 to that in 2008?
Your answer should be compact. 0.82. What is the ratio of the Claims(annual growth as % of broad money) of Panama in 2004 to that in 2008?
Make the answer very short. 0.46. What is the ratio of the Claims(annual growth as % of broad money) in Russian Federation in 2004 to that in 2008?
Keep it short and to the point. 1.02. What is the ratio of the Claims(annual growth as % of broad money) in St. Kitts and Nevis in 2004 to that in 2008?
Your answer should be very brief. 1.69. What is the ratio of the Claims(annual growth as % of broad money) of Azerbaijan in 2005 to that in 2006?
Your answer should be very brief. 0.65. What is the ratio of the Claims(annual growth as % of broad money) in Panama in 2005 to that in 2006?
Your answer should be very brief. 1.21. What is the ratio of the Claims(annual growth as % of broad money) in Russian Federation in 2005 to that in 2006?
Ensure brevity in your answer.  0.72. What is the ratio of the Claims(annual growth as % of broad money) in St. Kitts and Nevis in 2005 to that in 2006?
Give a very brief answer. 0.82. What is the ratio of the Claims(annual growth as % of broad money) of Azerbaijan in 2005 to that in 2007?
Give a very brief answer. 0.5. What is the ratio of the Claims(annual growth as % of broad money) in Panama in 2005 to that in 2007?
Your response must be concise. 0.8. What is the ratio of the Claims(annual growth as % of broad money) in Russian Federation in 2005 to that in 2007?
Provide a succinct answer. 0.67. What is the ratio of the Claims(annual growth as % of broad money) of St. Kitts and Nevis in 2005 to that in 2007?
Offer a terse response. 0.86. What is the ratio of the Claims(annual growth as % of broad money) of Azerbaijan in 2005 to that in 2008?
Keep it short and to the point. 0.79. What is the ratio of the Claims(annual growth as % of broad money) in Panama in 2005 to that in 2008?
Your answer should be compact. 0.91. What is the ratio of the Claims(annual growth as % of broad money) in Russian Federation in 2005 to that in 2008?
Keep it short and to the point. 0.84. What is the ratio of the Claims(annual growth as % of broad money) in St. Kitts and Nevis in 2005 to that in 2008?
Your response must be concise. 0.97. What is the ratio of the Claims(annual growth as % of broad money) of Azerbaijan in 2006 to that in 2007?
Keep it short and to the point. 0.77. What is the ratio of the Claims(annual growth as % of broad money) of Panama in 2006 to that in 2007?
Provide a succinct answer. 0.66. What is the ratio of the Claims(annual growth as % of broad money) in Russian Federation in 2006 to that in 2007?
Your answer should be very brief. 0.93. What is the ratio of the Claims(annual growth as % of broad money) in St. Kitts and Nevis in 2006 to that in 2007?
Your answer should be very brief. 1.05. What is the ratio of the Claims(annual growth as % of broad money) in Azerbaijan in 2006 to that in 2008?
Your response must be concise. 1.21. What is the ratio of the Claims(annual growth as % of broad money) of Panama in 2006 to that in 2008?
Provide a succinct answer. 0.75. What is the ratio of the Claims(annual growth as % of broad money) in Russian Federation in 2006 to that in 2008?
Provide a succinct answer. 1.16. What is the ratio of the Claims(annual growth as % of broad money) of St. Kitts and Nevis in 2006 to that in 2008?
Offer a terse response. 1.18. What is the ratio of the Claims(annual growth as % of broad money) of Azerbaijan in 2007 to that in 2008?
Provide a short and direct response. 1.58. What is the ratio of the Claims(annual growth as % of broad money) of Panama in 2007 to that in 2008?
Ensure brevity in your answer.  1.13. What is the ratio of the Claims(annual growth as % of broad money) in Russian Federation in 2007 to that in 2008?
Keep it short and to the point. 1.25. What is the ratio of the Claims(annual growth as % of broad money) of St. Kitts and Nevis in 2007 to that in 2008?
Keep it short and to the point. 1.13. What is the difference between the highest and the second highest Claims(annual growth as % of broad money) in Azerbaijan?
Offer a terse response. 15.63. What is the difference between the highest and the second highest Claims(annual growth as % of broad money) of Panama?
Your response must be concise. 2.2. What is the difference between the highest and the second highest Claims(annual growth as % of broad money) in Russian Federation?
Offer a terse response. 2.84. What is the difference between the highest and the second highest Claims(annual growth as % of broad money) of St. Kitts and Nevis?
Give a very brief answer. 3.44. What is the difference between the highest and the lowest Claims(annual growth as % of broad money) of Azerbaijan?
Your answer should be very brief. 46.32. What is the difference between the highest and the lowest Claims(annual growth as % of broad money) in Panama?
Your response must be concise. 18.81. What is the difference between the highest and the lowest Claims(annual growth as % of broad money) in Russian Federation?
Offer a very short reply. 14. What is the difference between the highest and the lowest Claims(annual growth as % of broad money) of St. Kitts and Nevis?
Offer a very short reply. 5.77. 